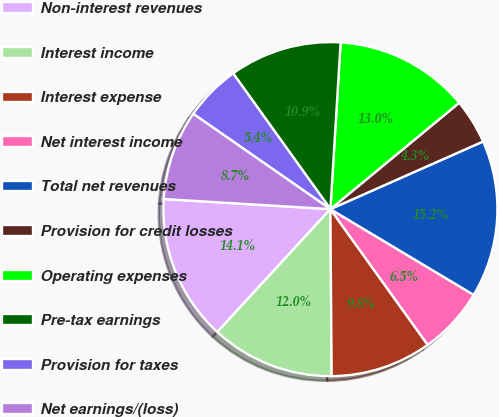<chart> <loc_0><loc_0><loc_500><loc_500><pie_chart><fcel>Non-interest revenues<fcel>Interest income<fcel>Interest expense<fcel>Net interest income<fcel>Total net revenues<fcel>Provision for credit losses<fcel>Operating expenses<fcel>Pre-tax earnings<fcel>Provision for taxes<fcel>Net earnings/(loss)<nl><fcel>14.13%<fcel>11.96%<fcel>9.78%<fcel>6.52%<fcel>15.22%<fcel>4.35%<fcel>13.04%<fcel>10.87%<fcel>5.44%<fcel>8.7%<nl></chart> 